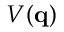<formula> <loc_0><loc_0><loc_500><loc_500>V ( q )</formula> 